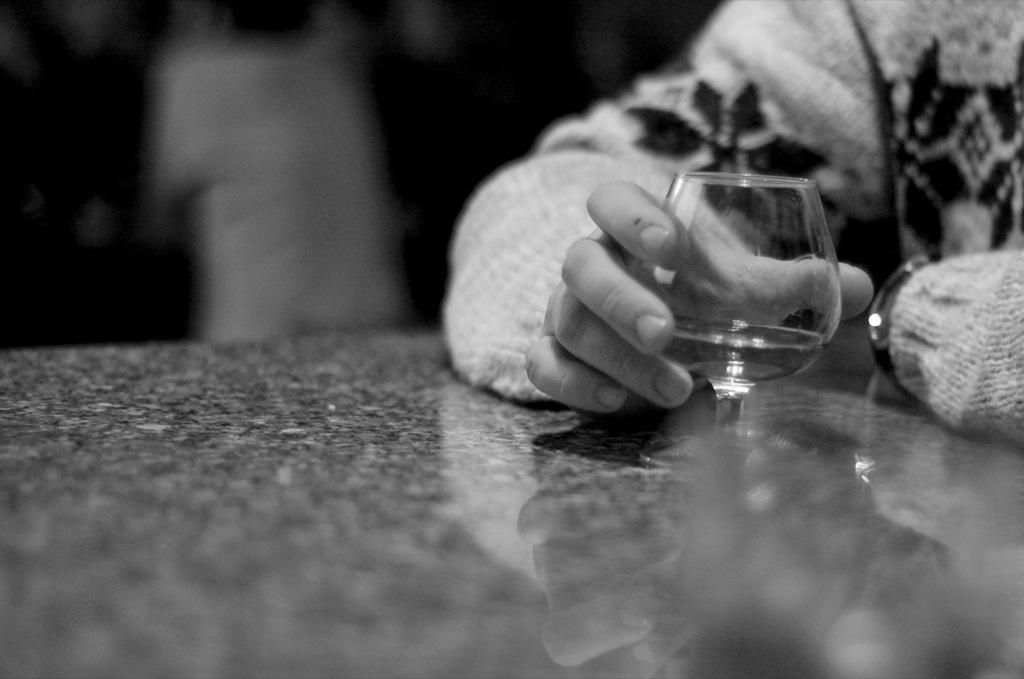What is the color scheme of the image? The image is black and white. What can be seen in the hand in the image? The hand is holding a glass. Where is the glass located in the image? The glass is on a table. Can you describe the background of the image? The background of the image is blurry. What type of clouds can be seen in the image? There are no clouds visible in the image, as it is black and white and focuses on a hand holding a glass. How is the glass being used to measure something in the image? The glass is not being used to measure anything in the image; it is simply being held by the hand. 